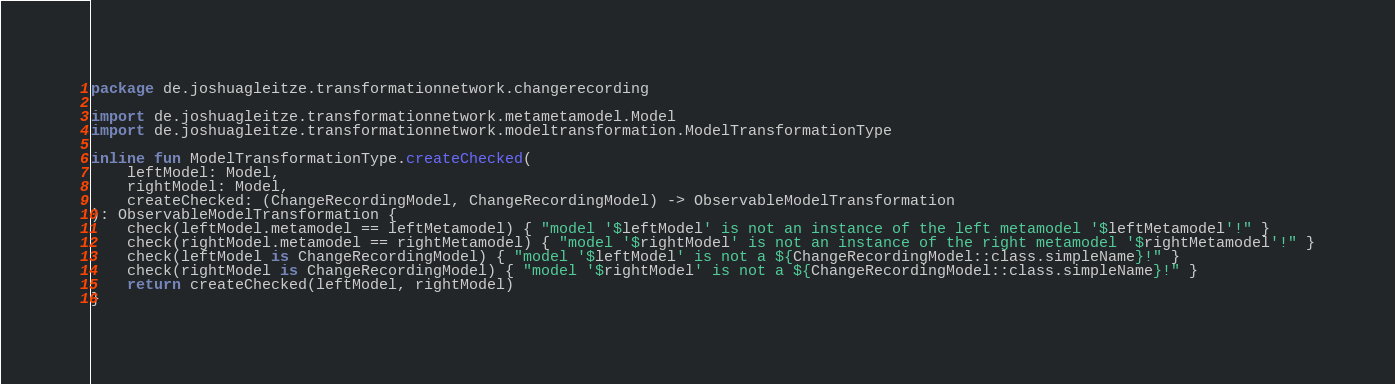Convert code to text. <code><loc_0><loc_0><loc_500><loc_500><_Kotlin_>package de.joshuagleitze.transformationnetwork.changerecording

import de.joshuagleitze.transformationnetwork.metametamodel.Model
import de.joshuagleitze.transformationnetwork.modeltransformation.ModelTransformationType

inline fun ModelTransformationType.createChecked(
    leftModel: Model,
    rightModel: Model,
    createChecked: (ChangeRecordingModel, ChangeRecordingModel) -> ObservableModelTransformation
): ObservableModelTransformation {
    check(leftModel.metamodel == leftMetamodel) { "model '$leftModel' is not an instance of the left metamodel '$leftMetamodel'!" }
    check(rightModel.metamodel == rightMetamodel) { "model '$rightModel' is not an instance of the right metamodel '$rightMetamodel'!" }
    check(leftModel is ChangeRecordingModel) { "model '$leftModel' is not a ${ChangeRecordingModel::class.simpleName}!" }
    check(rightModel is ChangeRecordingModel) { "model '$rightModel' is not a ${ChangeRecordingModel::class.simpleName}!" }
    return createChecked(leftModel, rightModel)
}
</code> 